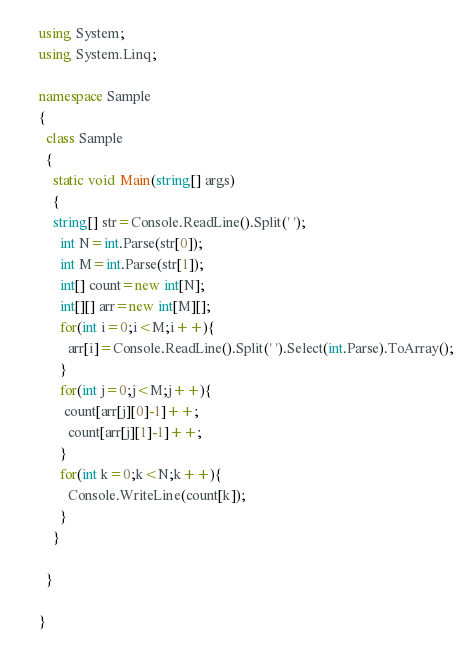<code> <loc_0><loc_0><loc_500><loc_500><_C#_>using System;
using System.Linq; 

namespace Sample
{
  class Sample
  {
    static void Main(string[] args)
    {
    string[] str=Console.ReadLine().Split(' ');
      int N=int.Parse(str[0]);
      int M=int.Parse(str[1]);
      int[] count=new int[N];
      int[][] arr=new int[M][];
      for(int i=0;i<M;i++){
        arr[i]=Console.ReadLine().Split(' ').Select(int.Parse).ToArray();
      }
      for(int j=0;j<M;j++){
       count[arr[j][0]-1]++; 
        count[arr[j][1]-1]++;
      }
      for(int k=0;k<N;k++){
        Console.WriteLine(count[k]);
      }
    }
    
  }

}</code> 